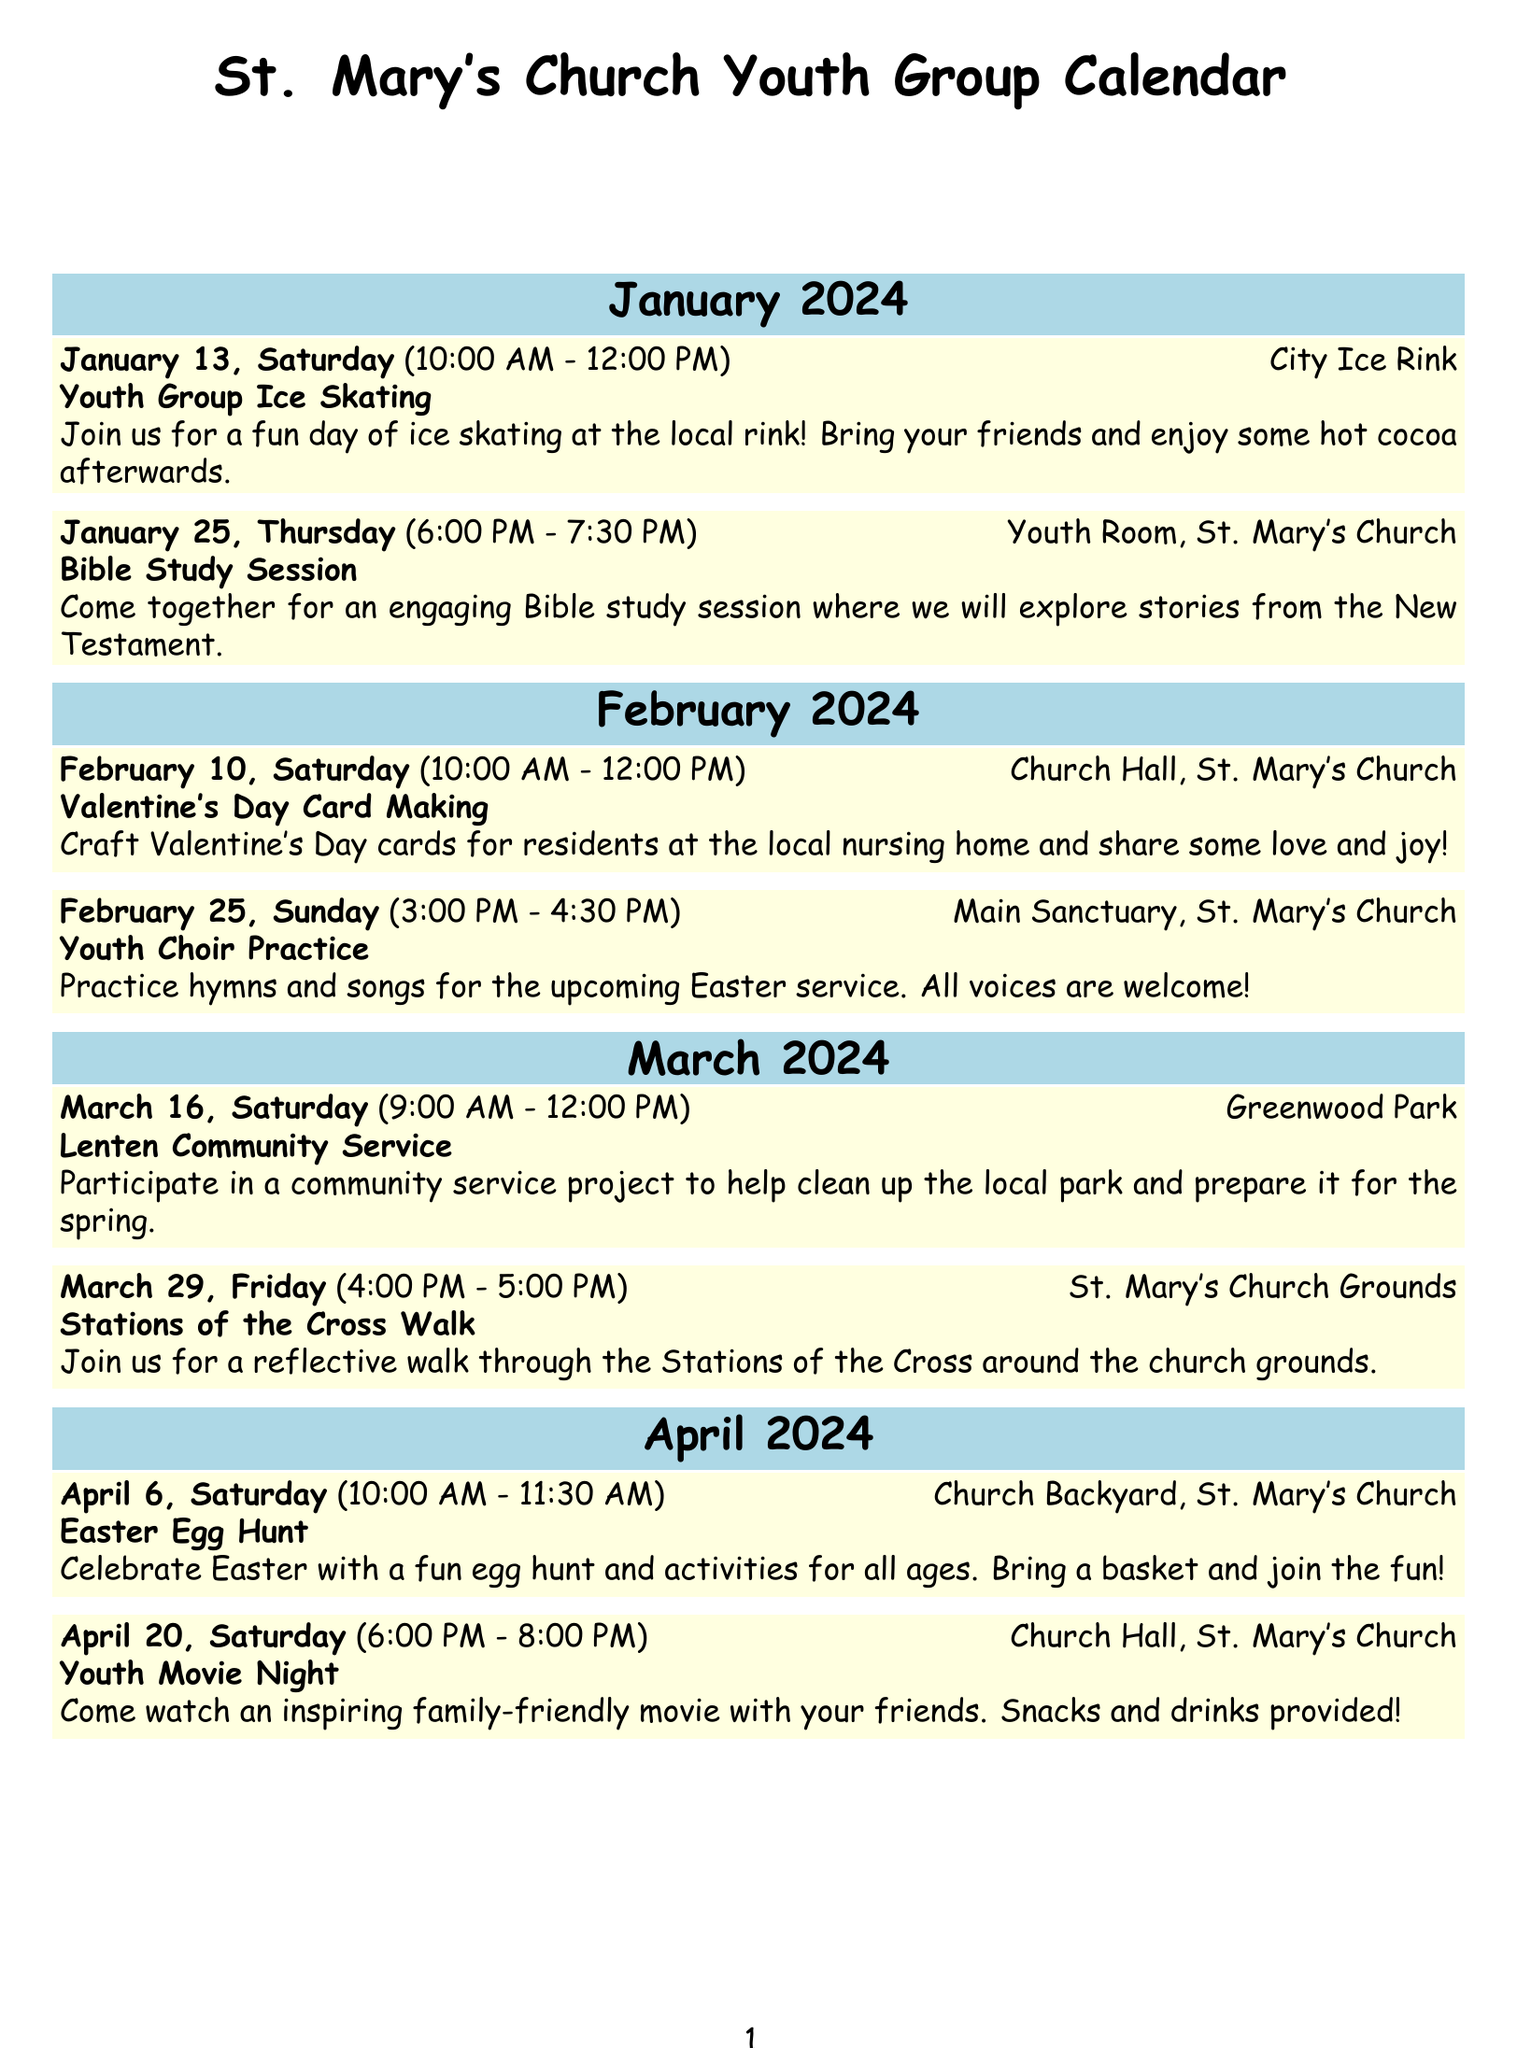What is the first event in January? The first event in January is on January 13, which is the Ice Skating event.
Answer: January 13, Saturday How long does the Bible Study Session last? The Bible Study Session is scheduled for one and a half hours, from 6:00 PM to 7:30 PM.
Answer: 1.5 hours What is the location for the Valentine's Day Card Making event? The Valentine's Day Card Making event takes place at the Church Hall in St. Mary's Church.
Answer: Church Hall, St. Mary's Church What event is scheduled for February 25? On February 25, there is a Youth Choir Practice in the Main Sanctuary.
Answer: Youth Choir Practice What type of activity is held on April 6? The activity on April 6 is an Easter Egg Hunt in the Church Backyard.
Answer: Easter Egg Hunt How many events are there in March? There are two events scheduled for March.
Answer: 2 events What is the main purpose of the Lenten Community Service? The purpose is to help clean up the local park and prepare it for spring.
Answer: Community service What time does the Youth Movie Night start? The Youth Movie Night starts at 6:00 PM.
Answer: 6:00 PM 